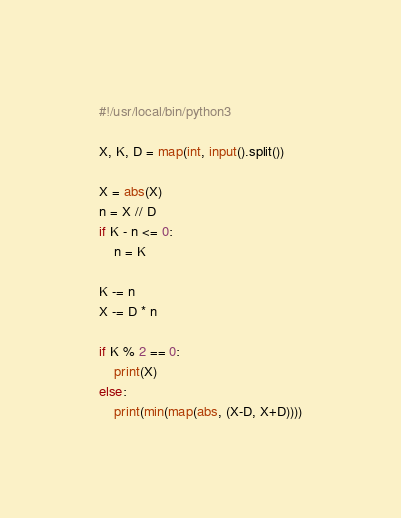<code> <loc_0><loc_0><loc_500><loc_500><_Python_>#!/usr/local/bin/python3

X, K, D = map(int, input().split())

X = abs(X)
n = X // D
if K - n <= 0:
    n = K

K -= n
X -= D * n

if K % 2 == 0:
    print(X)
else:
    print(min(map(abs, (X-D, X+D))))
</code> 